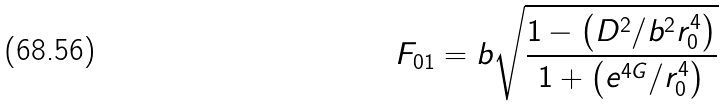<formula> <loc_0><loc_0><loc_500><loc_500>F _ { 0 1 } = b \sqrt { \frac { 1 - \left ( D ^ { 2 } / b ^ { 2 } r _ { 0 } ^ { 4 } \right ) } { 1 + \left ( e ^ { 4 G } / r _ { 0 } ^ { 4 } \right ) } }</formula> 